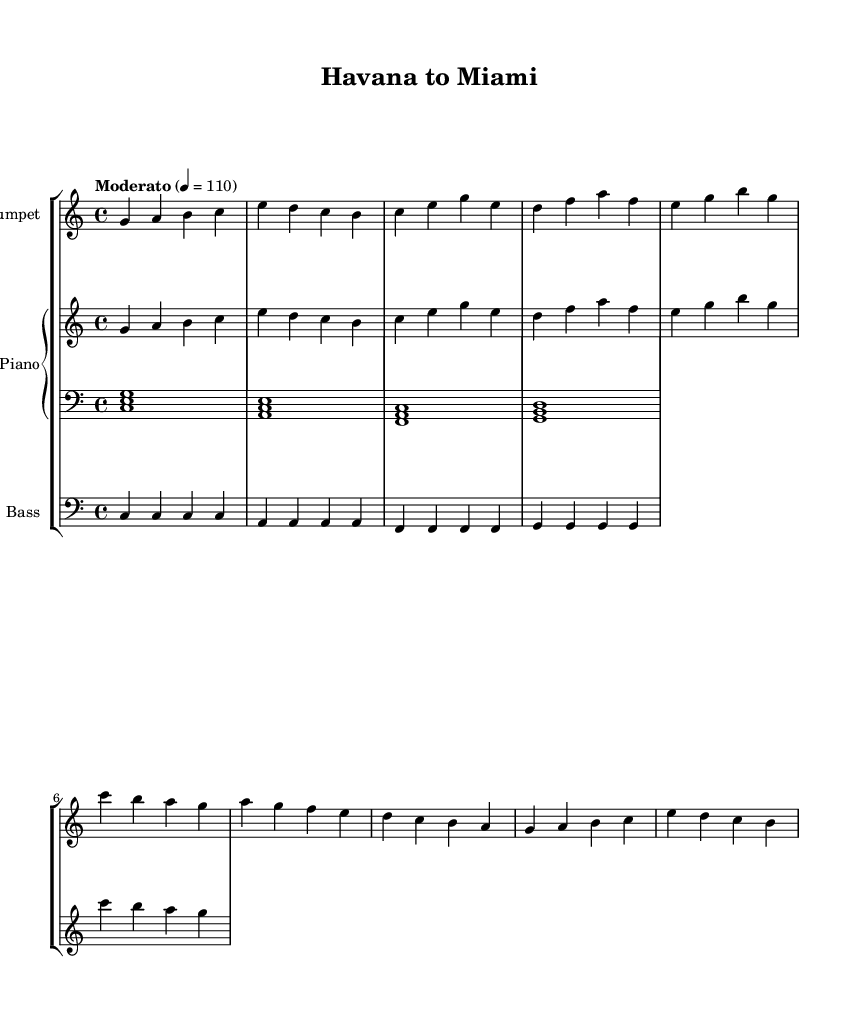What is the key signature of this music? The key signature is indicated at the beginning of the score, showing that it is in C major, which has no sharps or flats.
Answer: C major What is the time signature of this music? The time signature is located at the beginning of the score, displaying 4/4, which means there are four beats in each measure and the quarter note gets one beat.
Answer: 4/4 What is the tempo marking given for the piece? The tempo marking is written at the beginning of the score as "Moderato," which indicates a moderate pace, accompanied by a metronome marking of 110 beats per minute.
Answer: Moderato How many measures are in the A section? The A section consists of two lines of music, and by counting each group of notes separated by vertical lines (bars), we see that there are four measures in total for the A section.
Answer: 4 What is the chord progression for the piano left hand during the B section? By looking at the chord symbols played by the piano's left hand in the corresponding measures of the B section, we can see it follows a simple progression of chords, which are C major, A minor, F major, and G major, typically used in jazz standards.
Answer: C, A minor, F, G What does the melody in the trumpet part primarily move through in the A section? The trumpet's melody primarily outlines a stepwise motion between the notes and emphasizes the root of the chord being played, showcasing the improvisational influences commonly found in Latin jazz.
Answer: Stepwise motion How does the bass line provide rhythmic support in this jazz piece? The bass line is designed to outline the root notes of the chord changes on the beats, providing a strong rhythmic foundation while also complementing the melodic lines by emphasizing the syncopated feel typical in jazz and Latin styles.
Answer: Rhythmic foundation 